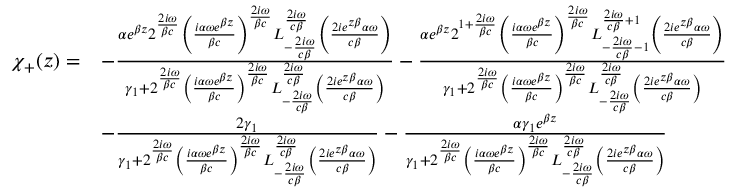Convert formula to latex. <formula><loc_0><loc_0><loc_500><loc_500>\begin{array} { r l } { \chi _ { + } ( z ) = } & { - \frac { \alpha e ^ { \beta z } 2 ^ { \frac { 2 i \omega } { \beta c } } \left ( \frac { i \alpha \omega e ^ { \beta z } } { \beta c } \right ) ^ { \frac { 2 i \omega } { \beta c } } L _ { - \frac { 2 i \omega } { c \beta } } ^ { \frac { 2 i \omega } { c \beta } } \left ( \frac { 2 i e ^ { z \beta } \alpha \omega } { c \beta } \right ) } { \gamma _ { 1 } + 2 ^ { \frac { 2 i \omega } { \beta c } } \left ( \frac { i \alpha \omega e ^ { \beta z } } { \beta c } \right ) ^ { \frac { 2 i \omega } { \beta c } } L _ { - \frac { 2 i \omega } { c \beta } } ^ { \frac { 2 i \omega } { c \beta } } \left ( \frac { 2 i e ^ { z \beta } \alpha \omega } { c \beta } \right ) } - \frac { \alpha e ^ { \beta z } 2 ^ { 1 + \frac { 2 i \omega } { \beta c } } \left ( \frac { i \alpha \omega e ^ { \beta z } } { \beta c } \right ) ^ { \frac { 2 i \omega } { \beta c } } L _ { - \frac { 2 i \omega } { c \beta } - 1 } ^ { \frac { 2 i \omega } { c \beta } + 1 } \left ( \frac { 2 i e ^ { z \beta } \alpha \omega } { c \beta } \right ) } { \gamma _ { 1 } + 2 ^ { \frac { 2 i \omega } { \beta c } } \left ( \frac { i \alpha \omega e ^ { \beta z } } { \beta c } \right ) ^ { \frac { 2 i \omega } { \beta c } } L _ { - \frac { 2 i \omega } { c \beta } } ^ { \frac { 2 i \omega } { c \beta } } \left ( \frac { 2 i e ^ { z \beta } \alpha \omega } { c \beta } \right ) } } \\ & { - \frac { 2 \gamma _ { 1 } } { \gamma _ { 1 } + 2 ^ { \frac { 2 i \omega } { \beta c } } \left ( \frac { i \alpha \omega e ^ { \beta z } } { \beta c } \right ) ^ { \frac { 2 i \omega } { \beta c } } L _ { - \frac { 2 i \omega } { c \beta } } ^ { \frac { 2 i \omega } { c \beta } } \left ( \frac { 2 i e ^ { z \beta } \alpha \omega } { c \beta } \right ) } - \frac { \alpha \gamma _ { 1 } e ^ { \beta z } } { \gamma _ { 1 } + 2 ^ { \frac { 2 i \omega } { \beta c } } \left ( \frac { i \alpha \omega e ^ { \beta z } } { \beta c } \right ) ^ { \frac { 2 i \omega } { \beta c } } L _ { - \frac { 2 i \omega } { c \beta } } ^ { \frac { 2 i \omega } { c \beta } } \left ( \frac { 2 i e ^ { z \beta } \alpha \omega } { c \beta } \right ) } } \end{array}</formula> 